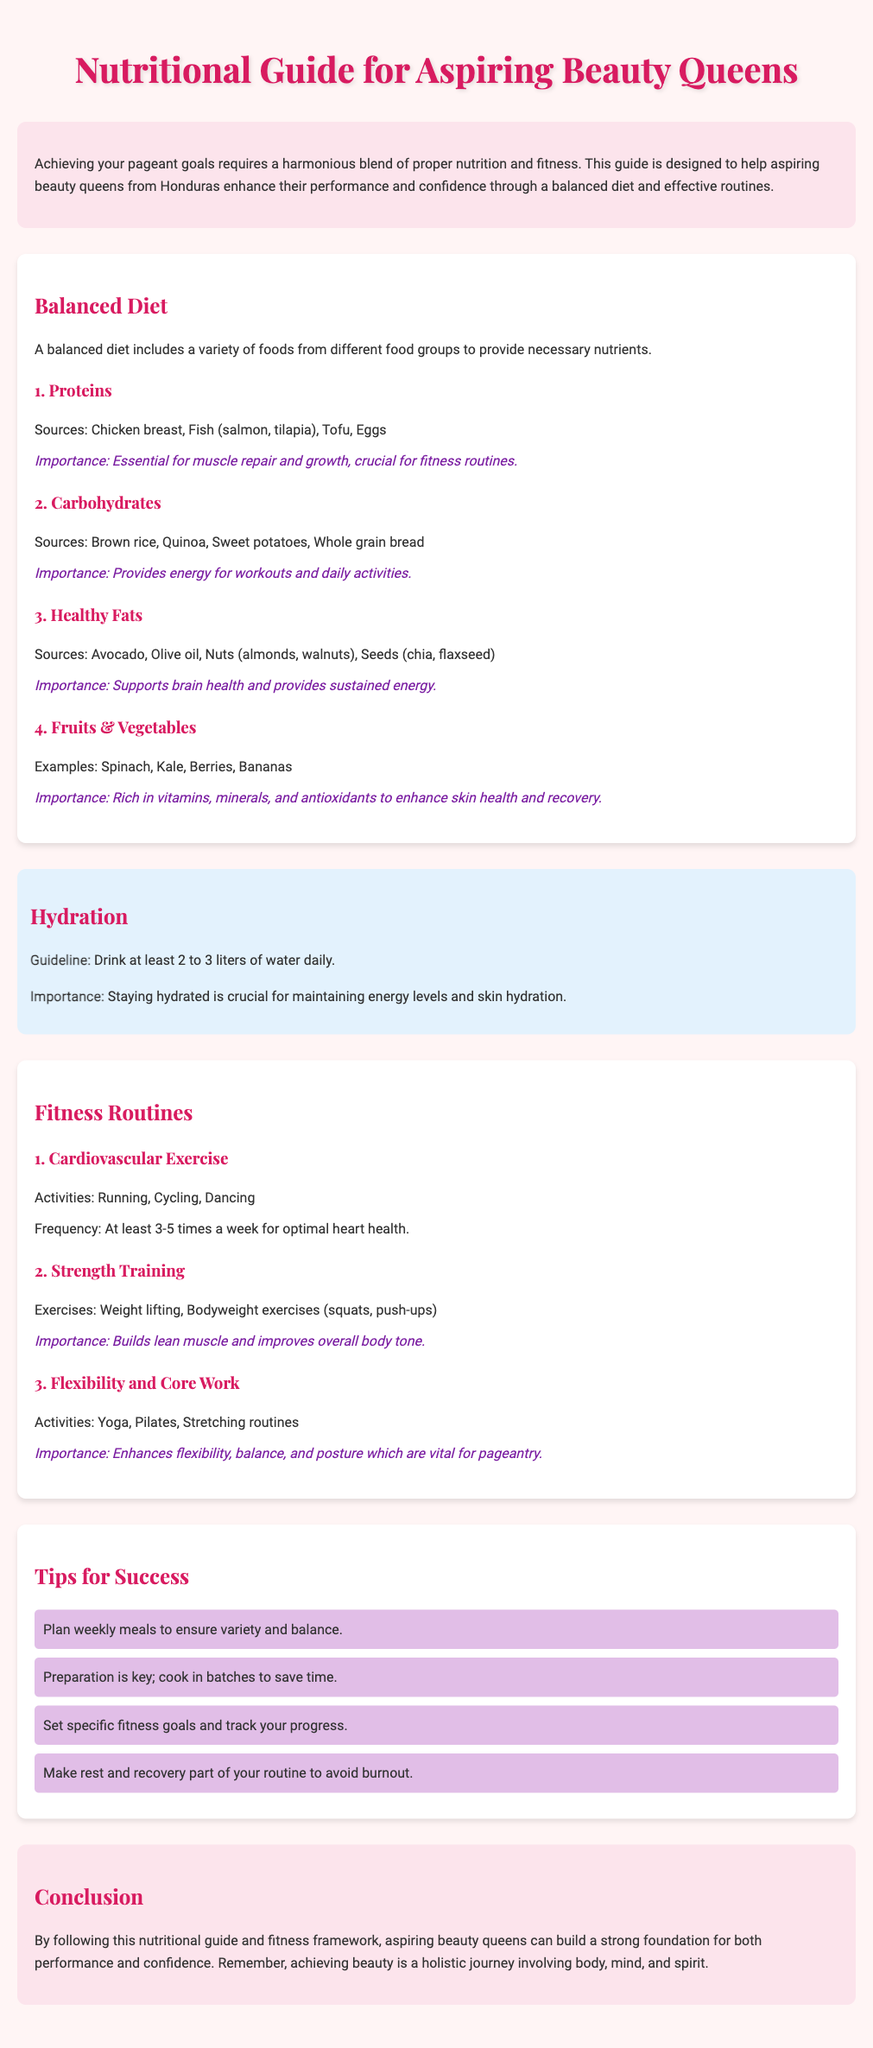What is the main purpose of the guide? The main purpose is to help aspiring beauty queens enhance their performance and confidence through a balanced diet and effective routines.
Answer: Enhance performance and confidence How many liters of water should one drink daily? The document states a guideline for water intake.
Answer: 2 to 3 liters What are two sources of proteins mentioned? The guide lists several sources of proteins, including chicken breast and fish.
Answer: Chicken breast, Fish What type of exercise is emphasized for heart health? The document suggests cardiovascular exercises for heart health.
Answer: Cardiovascular Exercise Which food group supports brain health? Healthy fats are indicated to support brain health in the document.
Answer: Healthy Fats What is the importance of fruits and vegetables? They are described as rich in vitamins, minerals, and antioxidants.
Answer: Enhance skin health and recovery What is a tip for meal planning? The guide offers several tips for success, one of which is related to meal planning.
Answer: Plan weekly meals How often should strength training be performed? The document does not specify frequency but emphasizes its importance.
Answer: Importance mentioned What activity is recommended for improving flexibility? The guide lists yoga, Pilates, and stretching as activities for flexibility.
Answer: Yoga 